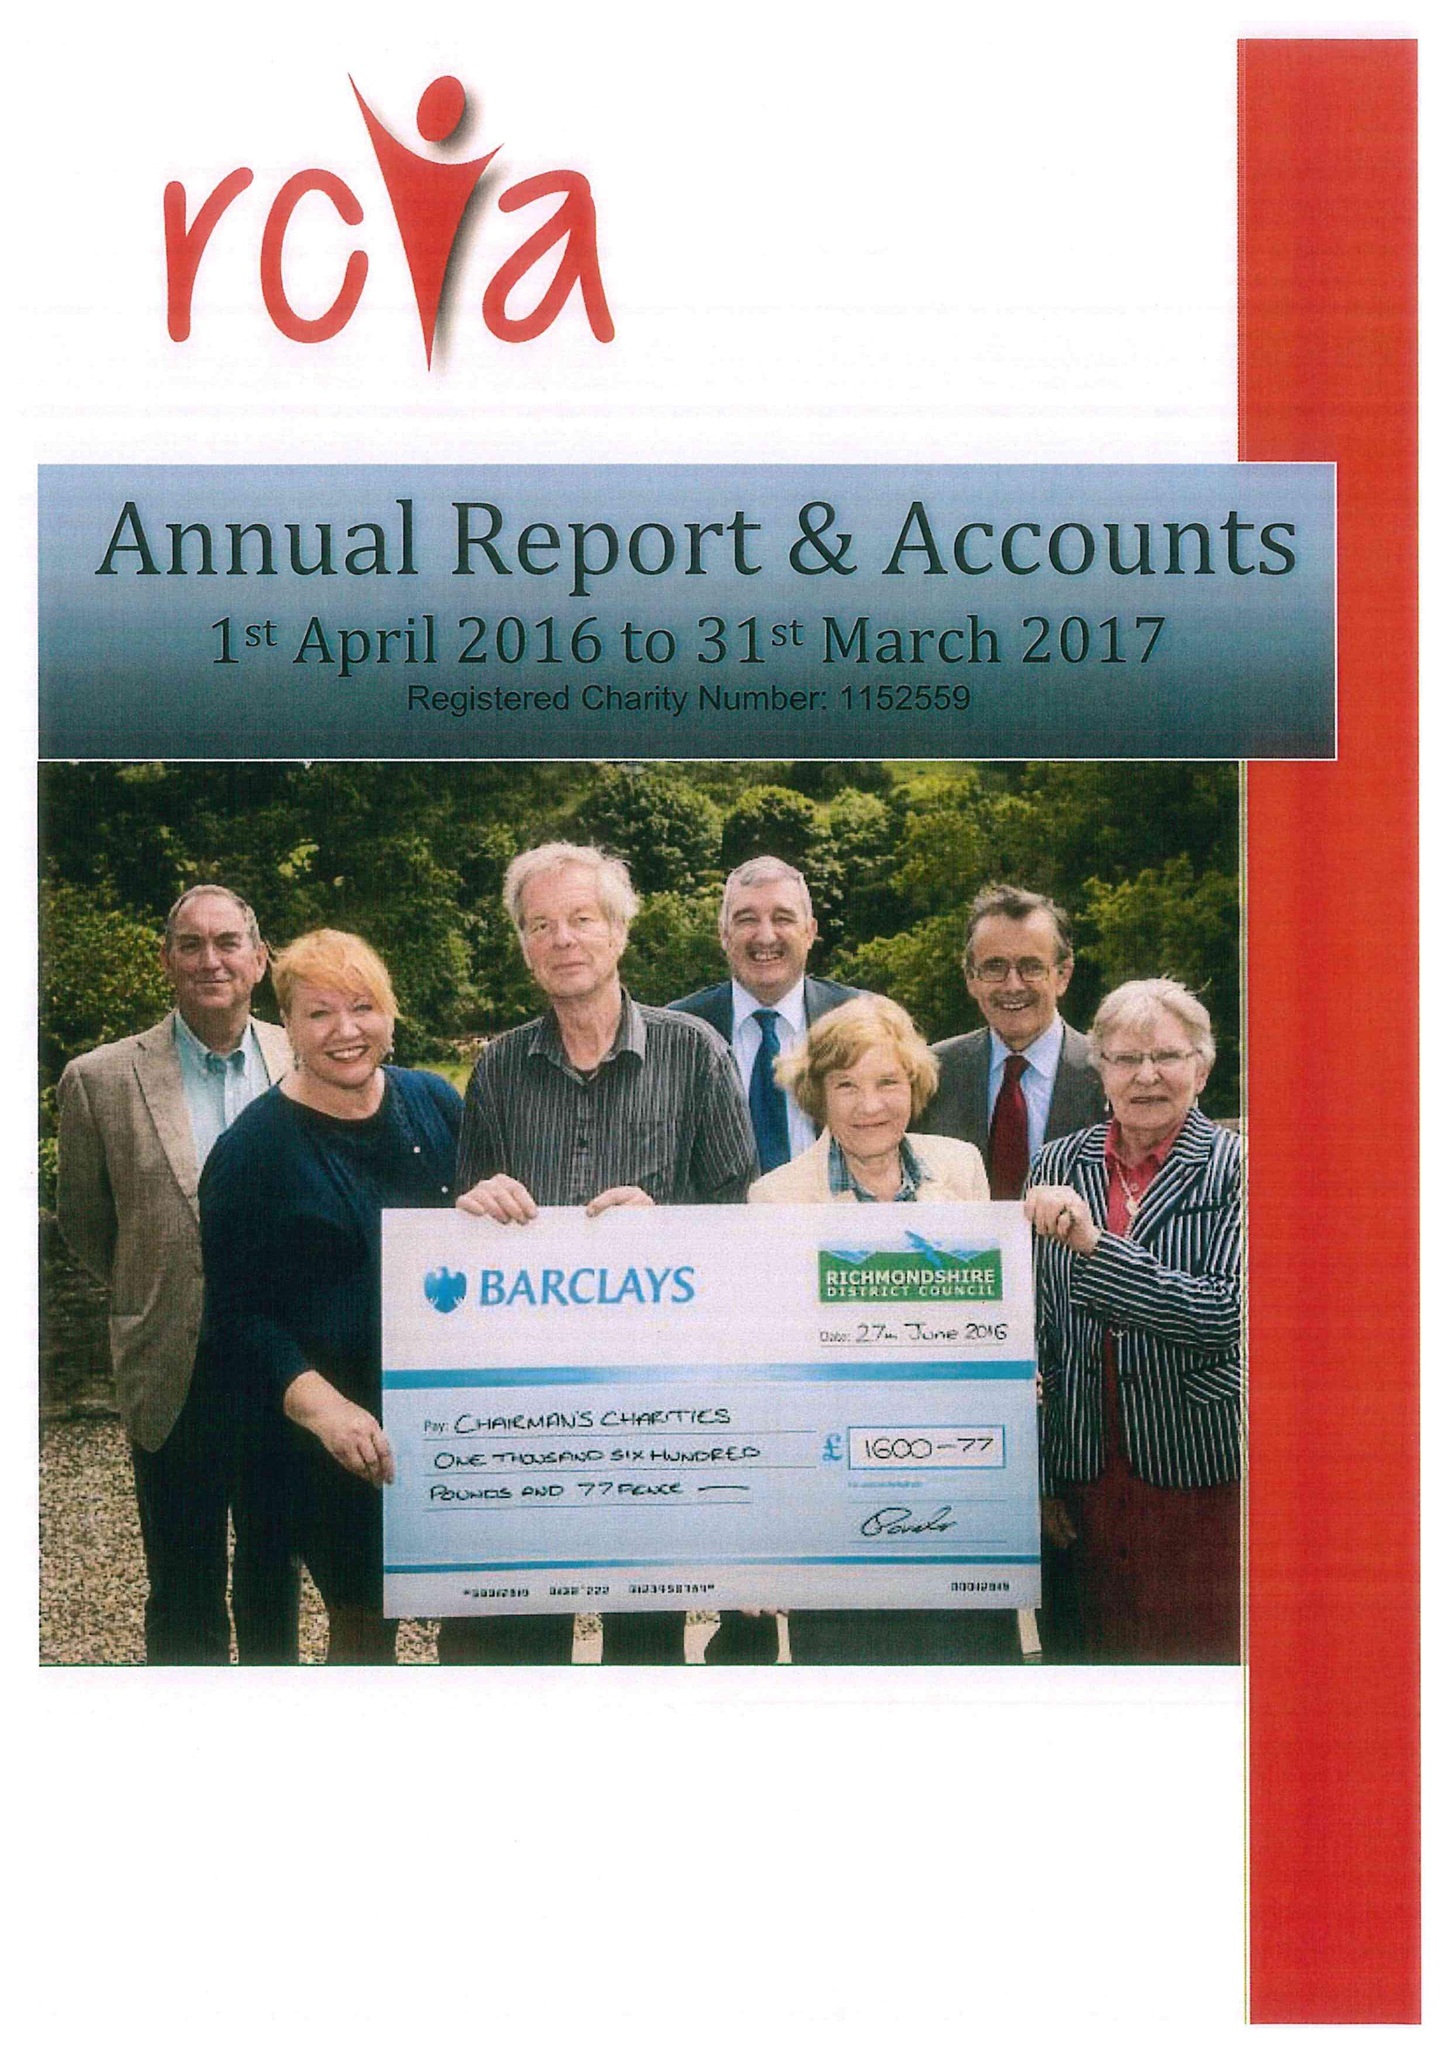What is the value for the income_annually_in_british_pounds?
Answer the question using a single word or phrase. 131227.00 